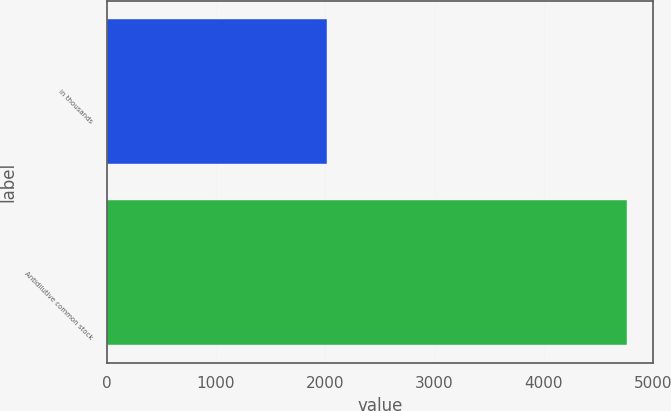Convert chart. <chart><loc_0><loc_0><loc_500><loc_500><bar_chart><fcel>in thousands<fcel>Antidilutive common stock<nl><fcel>2012<fcel>4762<nl></chart> 